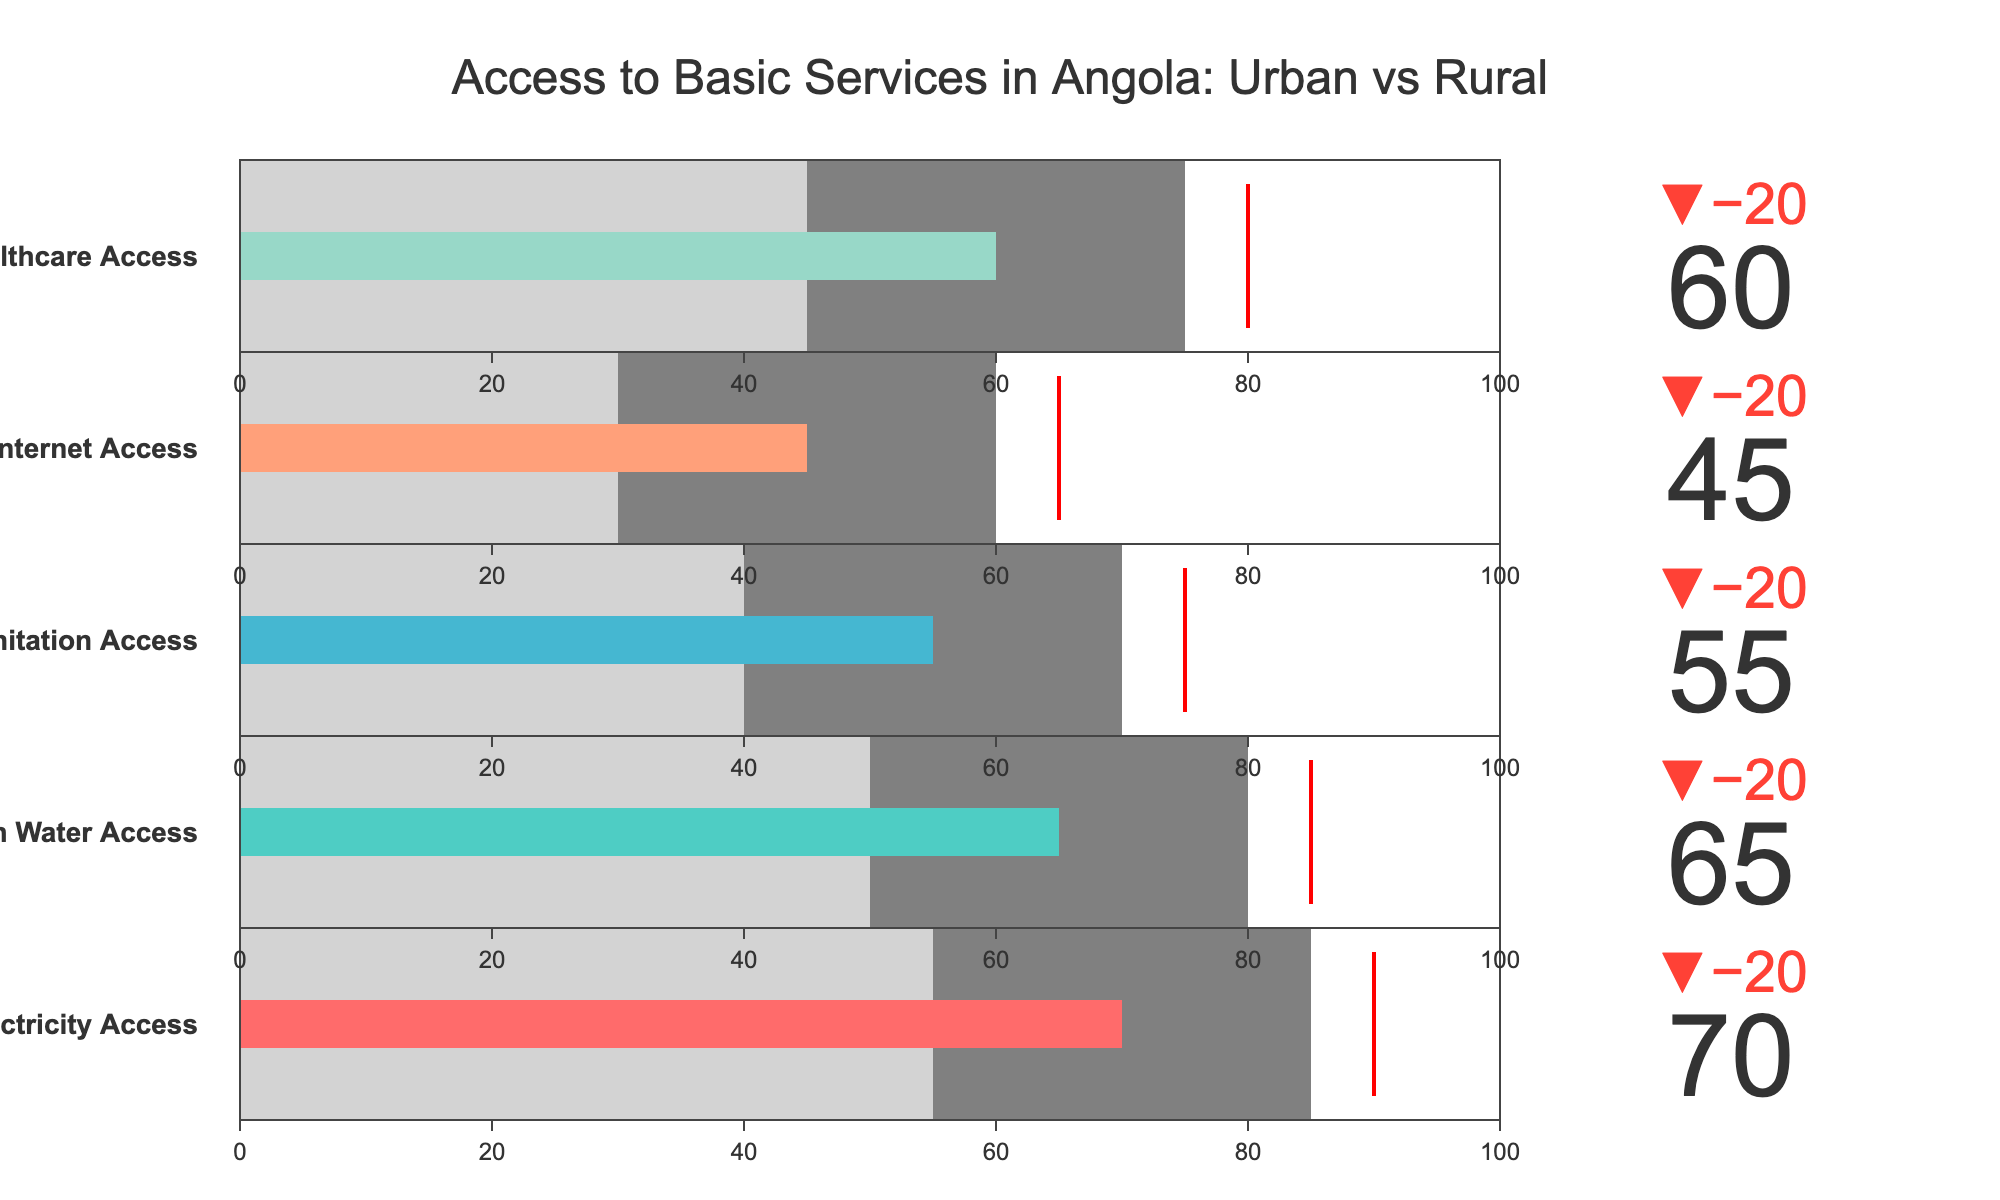What is the actual percentage of the population with access to clean water? The actual percentage of the population with access to clean water is explicitly indicated by the "Clean Water Access" bullet in the figure.
Answer: 65% Which basic service has the smallest actual percentage of access in rural areas? To find this, observe the rural values across all categories and identify the smallest one. The smallest rural value among the categories is for Internet Access (30%).
Answer: Internet Access By how much does actual access to healthcare in urban areas exceed that in rural areas? For Healthcare Access, compare the values for urban (75%) and rural areas (45%). Subtract the rural value from the urban value (75% - 45% = 30%).
Answer: 30% Which category shows the largest difference between its target and actual values? Calculate the difference between the target and actual values for each category and identify the largest one. The differences are: Electricity (20%), Clean Water (20%), Sanitation (20%), Internet (20%), Healthcare (20%). Since they are all tied, any of them can be an answer.
Answer: Electricity Access Is the urban population's access to sanitation above the halfway point on the scale? The urban population's access to sanitation is shown as 70% in the figure. Since 70% is above 50% on the scale, it is above the halfway point.
Answer: Yes What color represents the bar for Internet Access in the bullet chart? The bar colors for each category are distinct. Looking at the figure, the color for Internet Access is linked as the fourth category color, which is light salmon (or #FFA07A in coding terms).
Answer: Light Salmon Among the listed categories, which one has the highest target value? Check the target values for all listed categories and identify the highest one, which is Electricity Access with a target of 90%.
Answer: Electricity Access By what percentage does actual electricity access fall short of its target? Calculate the difference between the target and actual values for Electricity Access (90% - 70% = 20%).
Answer: 20% Compare the access to basic services between urban and rural areas. Which one has the greatest disparity? To find the greatest disparity, calculate the difference for each category between urban and rural values: Electricity (30%), Clean Water (30%), Sanitation (30%), Internet (30%), Healthcare (30%). Here, they are all tied with a 30% disparity.
Answer: Electricity, Clean Water, Sanitation, Internet, Healthcare Which category has an actual value closest to its target? Calculate the absolute difference between the actual value and the target for each category: Electricity (20%), Clean Water (20%), Sanitation (20%), Internet (20%), Healthcare (20%). All categories are tied, so any of them can be the answer.
Answer: Electricity Access 